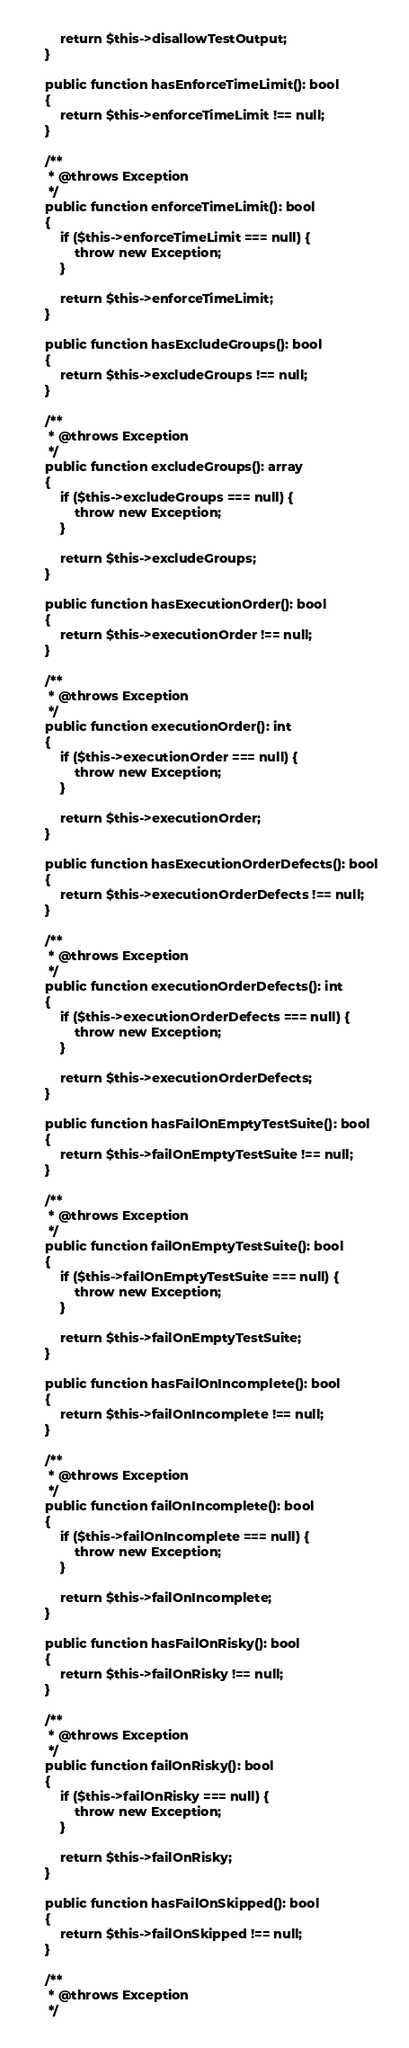Convert code to text. <code><loc_0><loc_0><loc_500><loc_500><_PHP_>
        return $this->disallowTestOutput;
    }

    public function hasEnforceTimeLimit(): bool
    {
        return $this->enforceTimeLimit !== null;
    }

    /**
     * @throws Exception
     */
    public function enforceTimeLimit(): bool
    {
        if ($this->enforceTimeLimit === null) {
            throw new Exception;
        }

        return $this->enforceTimeLimit;
    }

    public function hasExcludeGroups(): bool
    {
        return $this->excludeGroups !== null;
    }

    /**
     * @throws Exception
     */
    public function excludeGroups(): array
    {
        if ($this->excludeGroups === null) {
            throw new Exception;
        }

        return $this->excludeGroups;
    }

    public function hasExecutionOrder(): bool
    {
        return $this->executionOrder !== null;
    }

    /**
     * @throws Exception
     */
    public function executionOrder(): int
    {
        if ($this->executionOrder === null) {
            throw new Exception;
        }

        return $this->executionOrder;
    }

    public function hasExecutionOrderDefects(): bool
    {
        return $this->executionOrderDefects !== null;
    }

    /**
     * @throws Exception
     */
    public function executionOrderDefects(): int
    {
        if ($this->executionOrderDefects === null) {
            throw new Exception;
        }

        return $this->executionOrderDefects;
    }

    public function hasFailOnEmptyTestSuite(): bool
    {
        return $this->failOnEmptyTestSuite !== null;
    }

    /**
     * @throws Exception
     */
    public function failOnEmptyTestSuite(): bool
    {
        if ($this->failOnEmptyTestSuite === null) {
            throw new Exception;
        }

        return $this->failOnEmptyTestSuite;
    }

    public function hasFailOnIncomplete(): bool
    {
        return $this->failOnIncomplete !== null;
    }

    /**
     * @throws Exception
     */
    public function failOnIncomplete(): bool
    {
        if ($this->failOnIncomplete === null) {
            throw new Exception;
        }

        return $this->failOnIncomplete;
    }

    public function hasFailOnRisky(): bool
    {
        return $this->failOnRisky !== null;
    }

    /**
     * @throws Exception
     */
    public function failOnRisky(): bool
    {
        if ($this->failOnRisky === null) {
            throw new Exception;
        }

        return $this->failOnRisky;
    }

    public function hasFailOnSkipped(): bool
    {
        return $this->failOnSkipped !== null;
    }

    /**
     * @throws Exception
     */</code> 